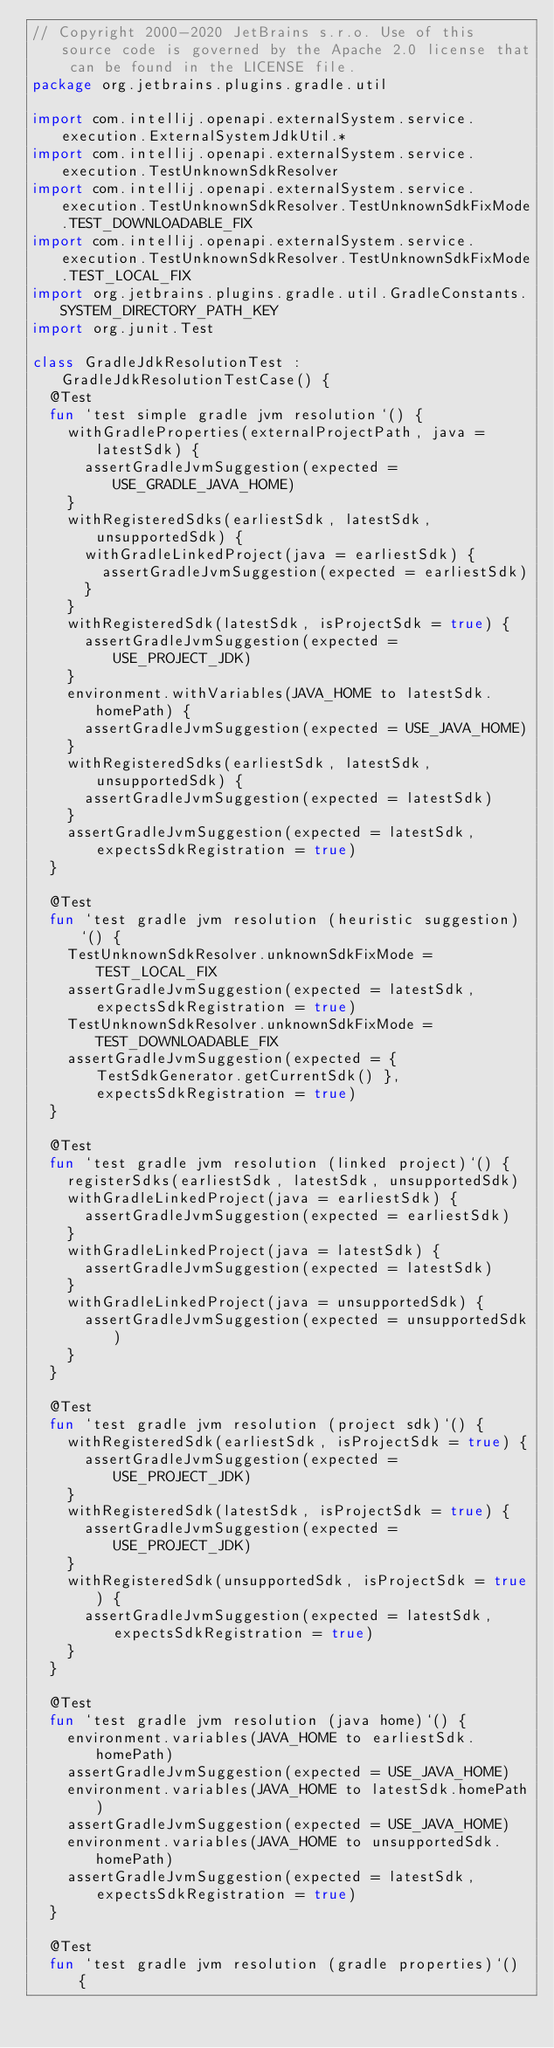<code> <loc_0><loc_0><loc_500><loc_500><_Kotlin_>// Copyright 2000-2020 JetBrains s.r.o. Use of this source code is governed by the Apache 2.0 license that can be found in the LICENSE file.
package org.jetbrains.plugins.gradle.util

import com.intellij.openapi.externalSystem.service.execution.ExternalSystemJdkUtil.*
import com.intellij.openapi.externalSystem.service.execution.TestUnknownSdkResolver
import com.intellij.openapi.externalSystem.service.execution.TestUnknownSdkResolver.TestUnknownSdkFixMode.TEST_DOWNLOADABLE_FIX
import com.intellij.openapi.externalSystem.service.execution.TestUnknownSdkResolver.TestUnknownSdkFixMode.TEST_LOCAL_FIX
import org.jetbrains.plugins.gradle.util.GradleConstants.SYSTEM_DIRECTORY_PATH_KEY
import org.junit.Test

class GradleJdkResolutionTest : GradleJdkResolutionTestCase() {
  @Test
  fun `test simple gradle jvm resolution`() {
    withGradleProperties(externalProjectPath, java = latestSdk) {
      assertGradleJvmSuggestion(expected = USE_GRADLE_JAVA_HOME)
    }
    withRegisteredSdks(earliestSdk, latestSdk, unsupportedSdk) {
      withGradleLinkedProject(java = earliestSdk) {
        assertGradleJvmSuggestion(expected = earliestSdk)
      }
    }
    withRegisteredSdk(latestSdk, isProjectSdk = true) {
      assertGradleJvmSuggestion(expected = USE_PROJECT_JDK)
    }
    environment.withVariables(JAVA_HOME to latestSdk.homePath) {
      assertGradleJvmSuggestion(expected = USE_JAVA_HOME)
    }
    withRegisteredSdks(earliestSdk, latestSdk, unsupportedSdk) {
      assertGradleJvmSuggestion(expected = latestSdk)
    }
    assertGradleJvmSuggestion(expected = latestSdk, expectsSdkRegistration = true)
  }

  @Test
  fun `test gradle jvm resolution (heuristic suggestion)`() {
    TestUnknownSdkResolver.unknownSdkFixMode = TEST_LOCAL_FIX
    assertGradleJvmSuggestion(expected = latestSdk, expectsSdkRegistration = true)
    TestUnknownSdkResolver.unknownSdkFixMode = TEST_DOWNLOADABLE_FIX
    assertGradleJvmSuggestion(expected = { TestSdkGenerator.getCurrentSdk() }, expectsSdkRegistration = true)
  }

  @Test
  fun `test gradle jvm resolution (linked project)`() {
    registerSdks(earliestSdk, latestSdk, unsupportedSdk)
    withGradleLinkedProject(java = earliestSdk) {
      assertGradleJvmSuggestion(expected = earliestSdk)
    }
    withGradleLinkedProject(java = latestSdk) {
      assertGradleJvmSuggestion(expected = latestSdk)
    }
    withGradleLinkedProject(java = unsupportedSdk) {
      assertGradleJvmSuggestion(expected = unsupportedSdk)
    }
  }

  @Test
  fun `test gradle jvm resolution (project sdk)`() {
    withRegisteredSdk(earliestSdk, isProjectSdk = true) {
      assertGradleJvmSuggestion(expected = USE_PROJECT_JDK)
    }
    withRegisteredSdk(latestSdk, isProjectSdk = true) {
      assertGradleJvmSuggestion(expected = USE_PROJECT_JDK)
    }
    withRegisteredSdk(unsupportedSdk, isProjectSdk = true) {
      assertGradleJvmSuggestion(expected = latestSdk, expectsSdkRegistration = true)
    }
  }

  @Test
  fun `test gradle jvm resolution (java home)`() {
    environment.variables(JAVA_HOME to earliestSdk.homePath)
    assertGradleJvmSuggestion(expected = USE_JAVA_HOME)
    environment.variables(JAVA_HOME to latestSdk.homePath)
    assertGradleJvmSuggestion(expected = USE_JAVA_HOME)
    environment.variables(JAVA_HOME to unsupportedSdk.homePath)
    assertGradleJvmSuggestion(expected = latestSdk, expectsSdkRegistration = true)
  }

  @Test
  fun `test gradle jvm resolution (gradle properties)`() {</code> 